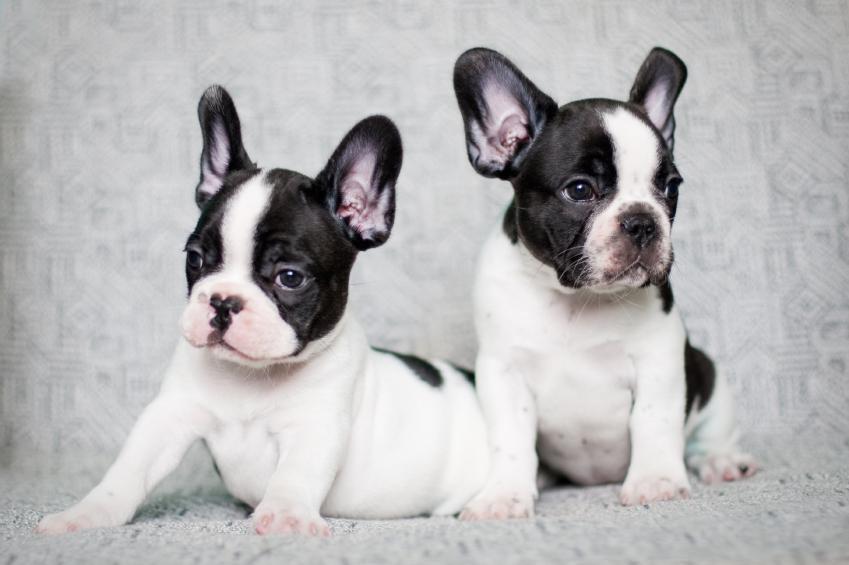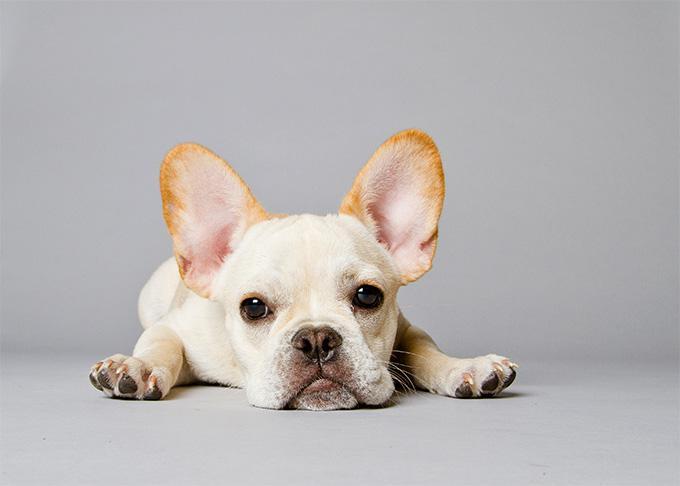The first image is the image on the left, the second image is the image on the right. For the images shown, is this caption "There is one dog lying on its stomach in the image on the right." true? Answer yes or no. Yes. 